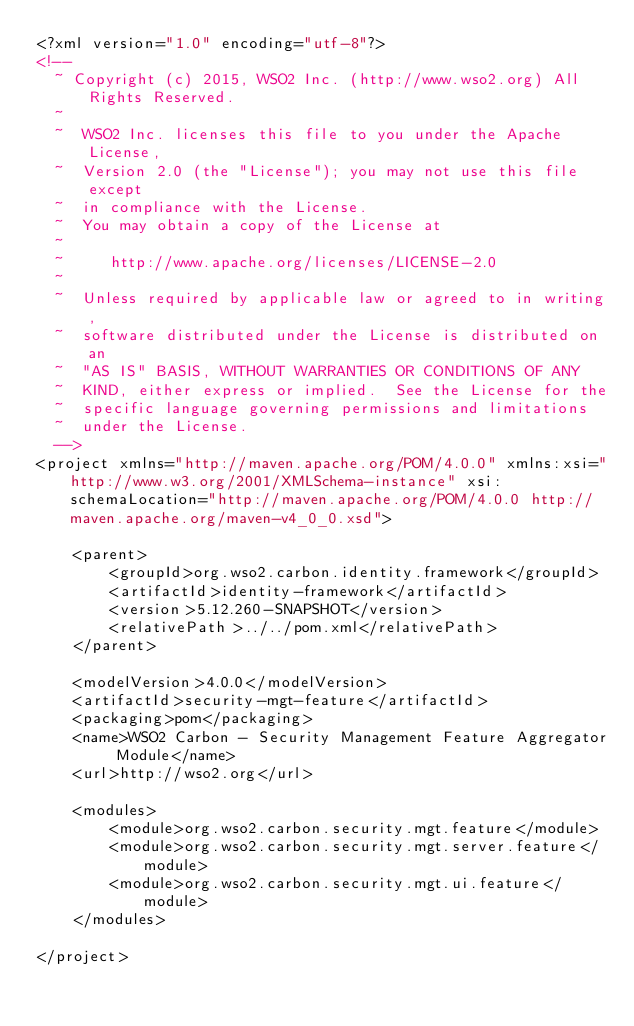<code> <loc_0><loc_0><loc_500><loc_500><_XML_><?xml version="1.0" encoding="utf-8"?>
<!--
  ~ Copyright (c) 2015, WSO2 Inc. (http://www.wso2.org) All Rights Reserved.
  ~
  ~  WSO2 Inc. licenses this file to you under the Apache License,
  ~  Version 2.0 (the "License"); you may not use this file except
  ~  in compliance with the License.
  ~  You may obtain a copy of the License at
  ~
  ~     http://www.apache.org/licenses/LICENSE-2.0
  ~
  ~  Unless required by applicable law or agreed to in writing,
  ~  software distributed under the License is distributed on an
  ~  "AS IS" BASIS, WITHOUT WARRANTIES OR CONDITIONS OF ANY
  ~  KIND, either express or implied.  See the License for the
  ~  specific language governing permissions and limitations
  ~  under the License.
  -->
<project xmlns="http://maven.apache.org/POM/4.0.0" xmlns:xsi="http://www.w3.org/2001/XMLSchema-instance" xsi:schemaLocation="http://maven.apache.org/POM/4.0.0 http://maven.apache.org/maven-v4_0_0.xsd">

    <parent>
        <groupId>org.wso2.carbon.identity.framework</groupId>
        <artifactId>identity-framework</artifactId>
        <version>5.12.260-SNAPSHOT</version>
        <relativePath>../../pom.xml</relativePath>
    </parent>

    <modelVersion>4.0.0</modelVersion>
    <artifactId>security-mgt-feature</artifactId>
    <packaging>pom</packaging>
    <name>WSO2 Carbon - Security Management Feature Aggregator Module</name>
    <url>http://wso2.org</url>

    <modules>
        <module>org.wso2.carbon.security.mgt.feature</module>
        <module>org.wso2.carbon.security.mgt.server.feature</module>
        <module>org.wso2.carbon.security.mgt.ui.feature</module>
    </modules>

</project>

</code> 